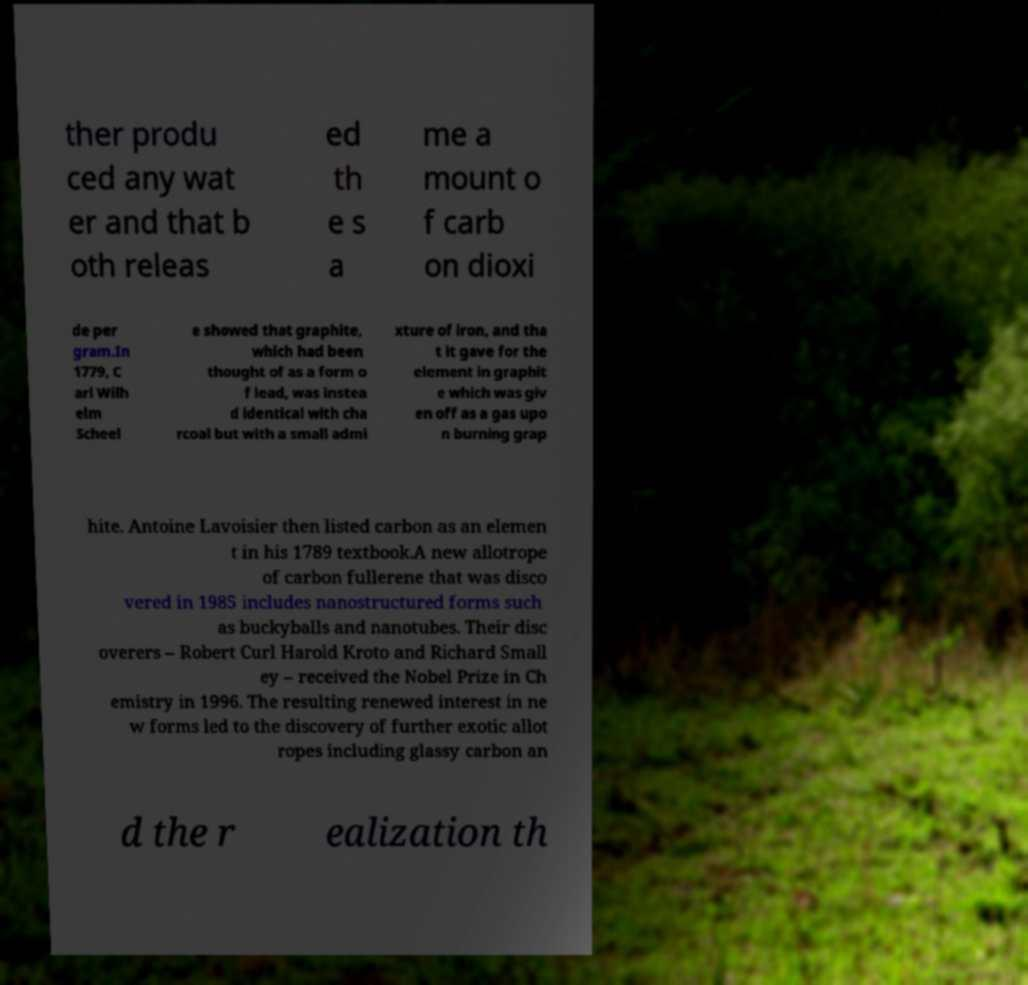There's text embedded in this image that I need extracted. Can you transcribe it verbatim? ther produ ced any wat er and that b oth releas ed th e s a me a mount o f carb on dioxi de per gram.In 1779, C arl Wilh elm Scheel e showed that graphite, which had been thought of as a form o f lead, was instea d identical with cha rcoal but with a small admi xture of iron, and tha t it gave for the element in graphit e which was giv en off as a gas upo n burning grap hite. Antoine Lavoisier then listed carbon as an elemen t in his 1789 textbook.A new allotrope of carbon fullerene that was disco vered in 1985 includes nanostructured forms such as buckyballs and nanotubes. Their disc overers – Robert Curl Harold Kroto and Richard Small ey – received the Nobel Prize in Ch emistry in 1996. The resulting renewed interest in ne w forms led to the discovery of further exotic allot ropes including glassy carbon an d the r ealization th 